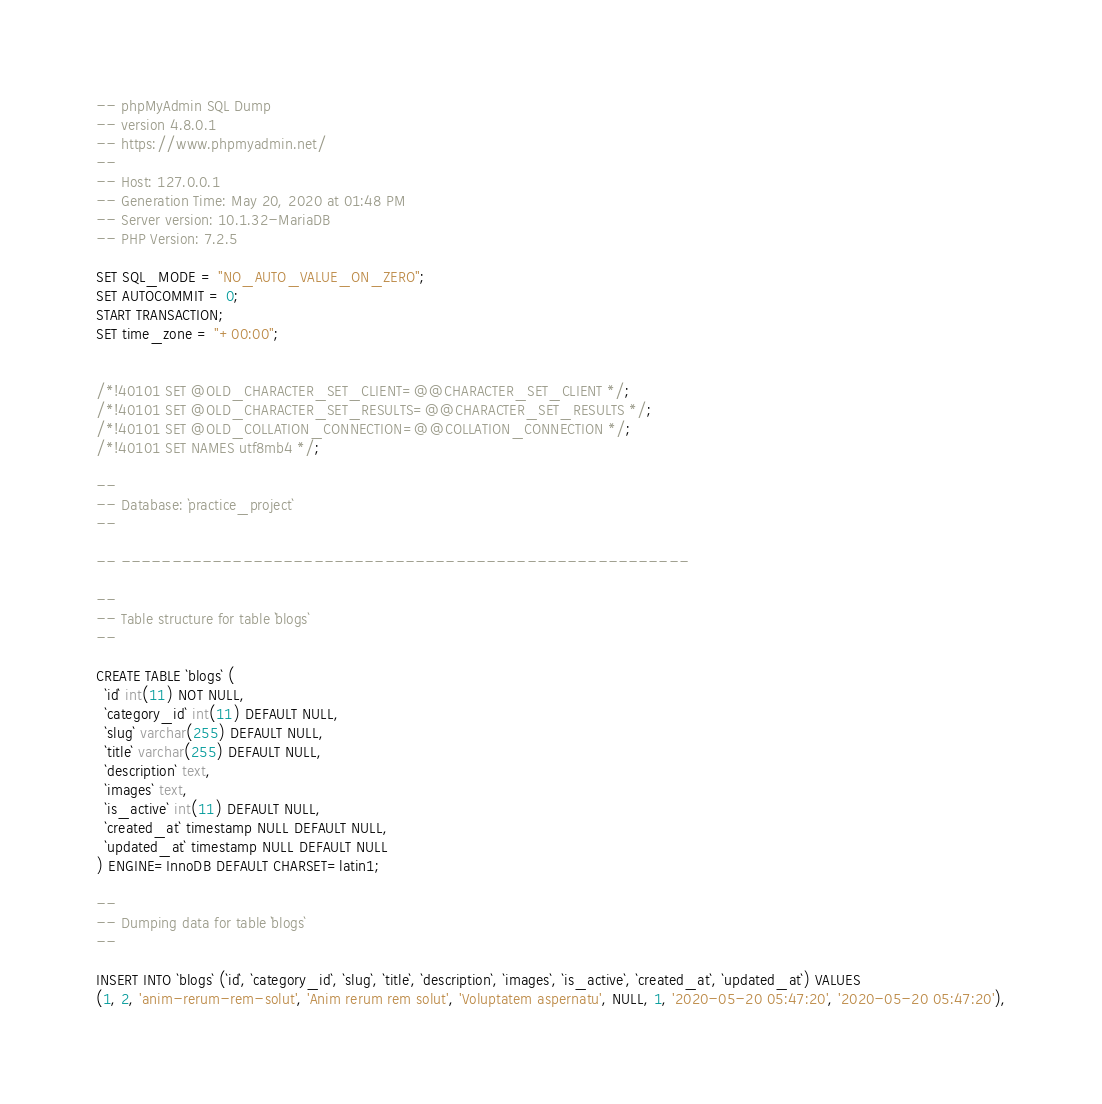<code> <loc_0><loc_0><loc_500><loc_500><_SQL_>-- phpMyAdmin SQL Dump
-- version 4.8.0.1
-- https://www.phpmyadmin.net/
--
-- Host: 127.0.0.1
-- Generation Time: May 20, 2020 at 01:48 PM
-- Server version: 10.1.32-MariaDB
-- PHP Version: 7.2.5

SET SQL_MODE = "NO_AUTO_VALUE_ON_ZERO";
SET AUTOCOMMIT = 0;
START TRANSACTION;
SET time_zone = "+00:00";


/*!40101 SET @OLD_CHARACTER_SET_CLIENT=@@CHARACTER_SET_CLIENT */;
/*!40101 SET @OLD_CHARACTER_SET_RESULTS=@@CHARACTER_SET_RESULTS */;
/*!40101 SET @OLD_COLLATION_CONNECTION=@@COLLATION_CONNECTION */;
/*!40101 SET NAMES utf8mb4 */;

--
-- Database: `practice_project`
--

-- --------------------------------------------------------

--
-- Table structure for table `blogs`
--

CREATE TABLE `blogs` (
  `id` int(11) NOT NULL,
  `category_id` int(11) DEFAULT NULL,
  `slug` varchar(255) DEFAULT NULL,
  `title` varchar(255) DEFAULT NULL,
  `description` text,
  `images` text,
  `is_active` int(11) DEFAULT NULL,
  `created_at` timestamp NULL DEFAULT NULL,
  `updated_at` timestamp NULL DEFAULT NULL
) ENGINE=InnoDB DEFAULT CHARSET=latin1;

--
-- Dumping data for table `blogs`
--

INSERT INTO `blogs` (`id`, `category_id`, `slug`, `title`, `description`, `images`, `is_active`, `created_at`, `updated_at`) VALUES
(1, 2, 'anim-rerum-rem-solut', 'Anim rerum rem solut', 'Voluptatem aspernatu', NULL, 1, '2020-05-20 05:47:20', '2020-05-20 05:47:20'),</code> 